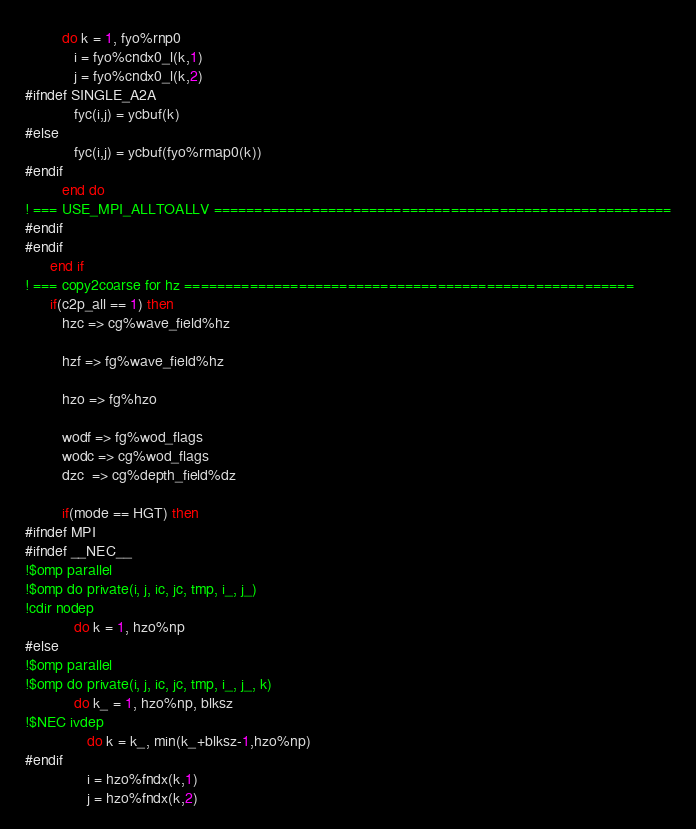Convert code to text. <code><loc_0><loc_0><loc_500><loc_500><_FORTRAN_>         do k = 1, fyo%rnp0
            i = fyo%cndx0_l(k,1)
            j = fyo%cndx0_l(k,2)
#ifndef SINGLE_A2A
            fyc(i,j) = ycbuf(k)
#else
            fyc(i,j) = ycbuf(fyo%rmap0(k))
#endif
         end do
! === USE_MPI_ALLTOALLV ========================================================
#endif
#endif
      end if
! === copy2coarse for hz =======================================================
      if(c2p_all == 1) then
         hzc => cg%wave_field%hz

         hzf => fg%wave_field%hz

         hzo => fg%hzo

         wodf => fg%wod_flags
         wodc => cg%wod_flags
         dzc  => cg%depth_field%dz

         if(mode == HGT) then
#ifndef MPI
#ifndef __NEC__
!$omp parallel
!$omp do private(i, j, ic, jc, tmp, i_, j_)
!cdir nodep
            do k = 1, hzo%np
#else
!$omp parallel
!$omp do private(i, j, ic, jc, tmp, i_, j_, k)
            do k_ = 1, hzo%np, blksz
!$NEC ivdep
               do k = k_, min(k_+blksz-1,hzo%np)
#endif
               i = hzo%fndx(k,1)
               j = hzo%fndx(k,2)</code> 